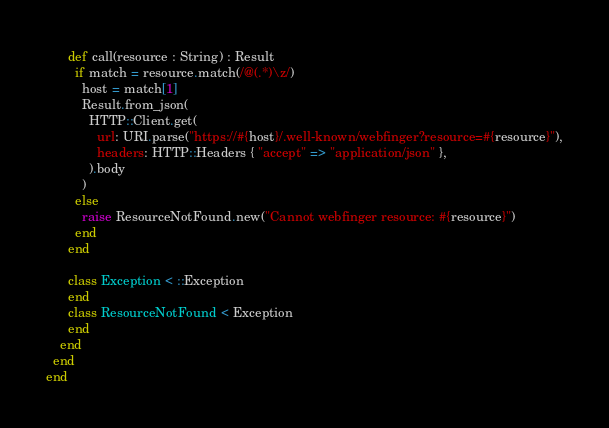Convert code to text. <code><loc_0><loc_0><loc_500><loc_500><_Crystal_>      def call(resource : String) : Result
        if match = resource.match(/@(.*)\z/)
          host = match[1]
          Result.from_json(
            HTTP::Client.get(
              url: URI.parse("https://#{host}/.well-known/webfinger?resource=#{resource}"),
              headers: HTTP::Headers { "accept" => "application/json" },
            ).body
          )
        else
          raise ResourceNotFound.new("Cannot webfinger resource: #{resource}")
        end
      end

      class Exception < ::Exception
      end
      class ResourceNotFound < Exception
      end
    end
  end
end
</code> 